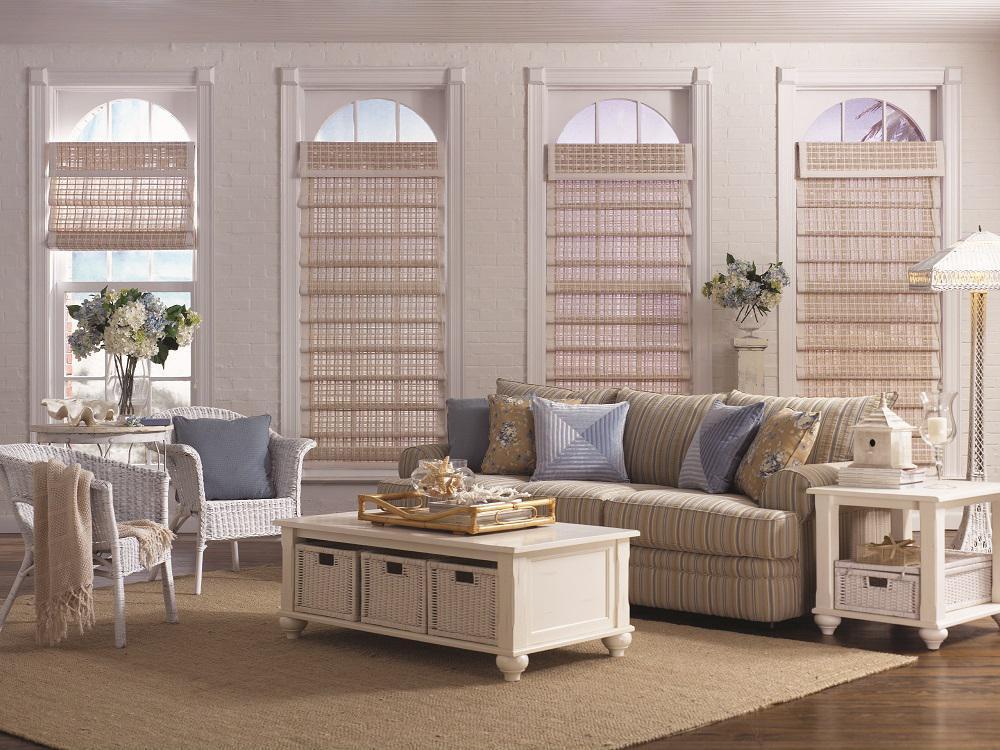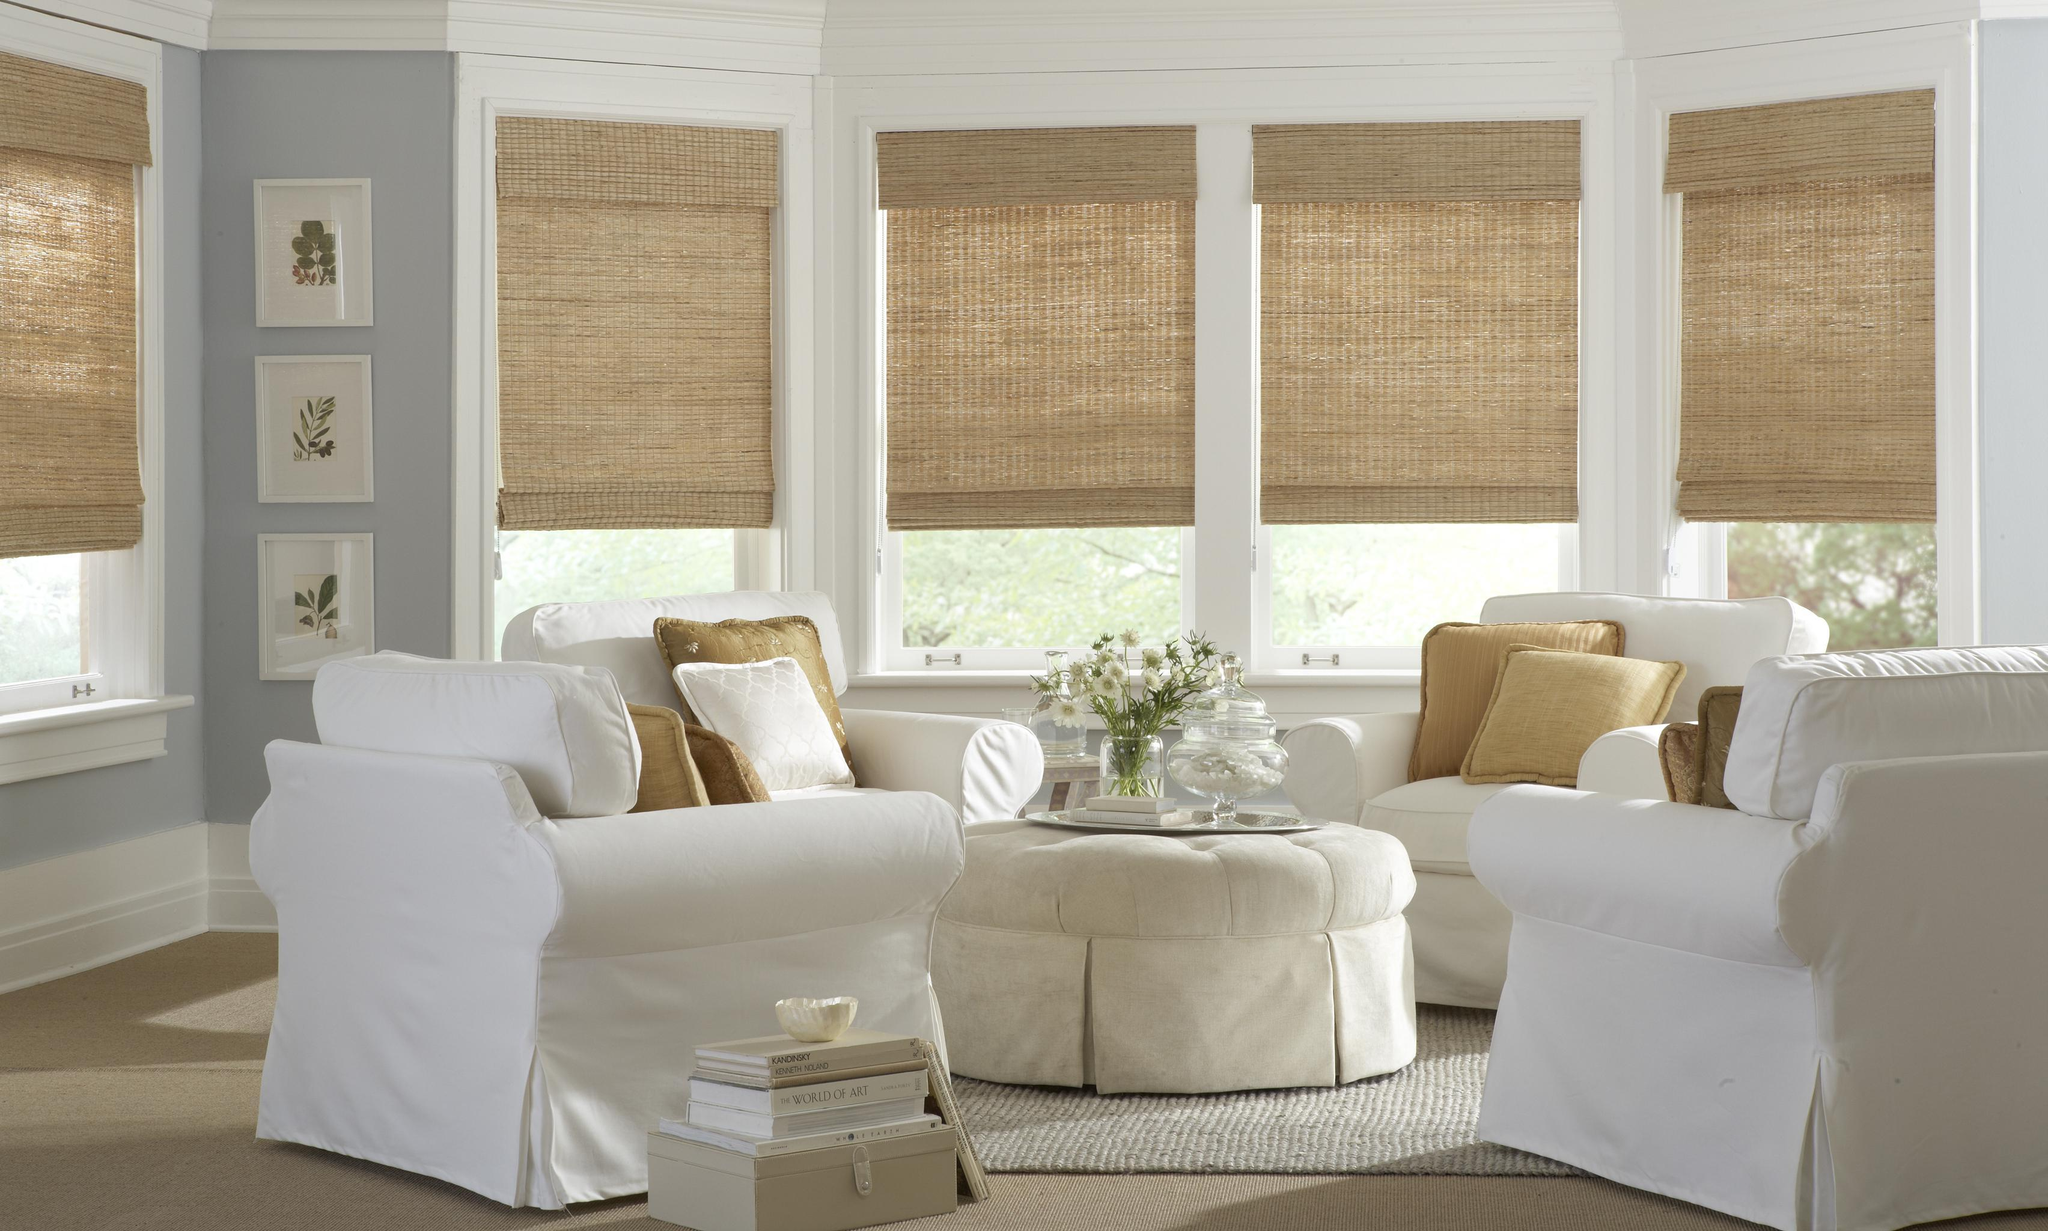The first image is the image on the left, the second image is the image on the right. Evaluate the accuracy of this statement regarding the images: "In at least one image there is a total of four beige blinds behind a sofa.". Is it true? Answer yes or no. Yes. The first image is the image on the left, the second image is the image on the right. For the images shown, is this caption "The right image features a room with at least three windows with rolled up shades printed with bold geometric patterns." true? Answer yes or no. No. 